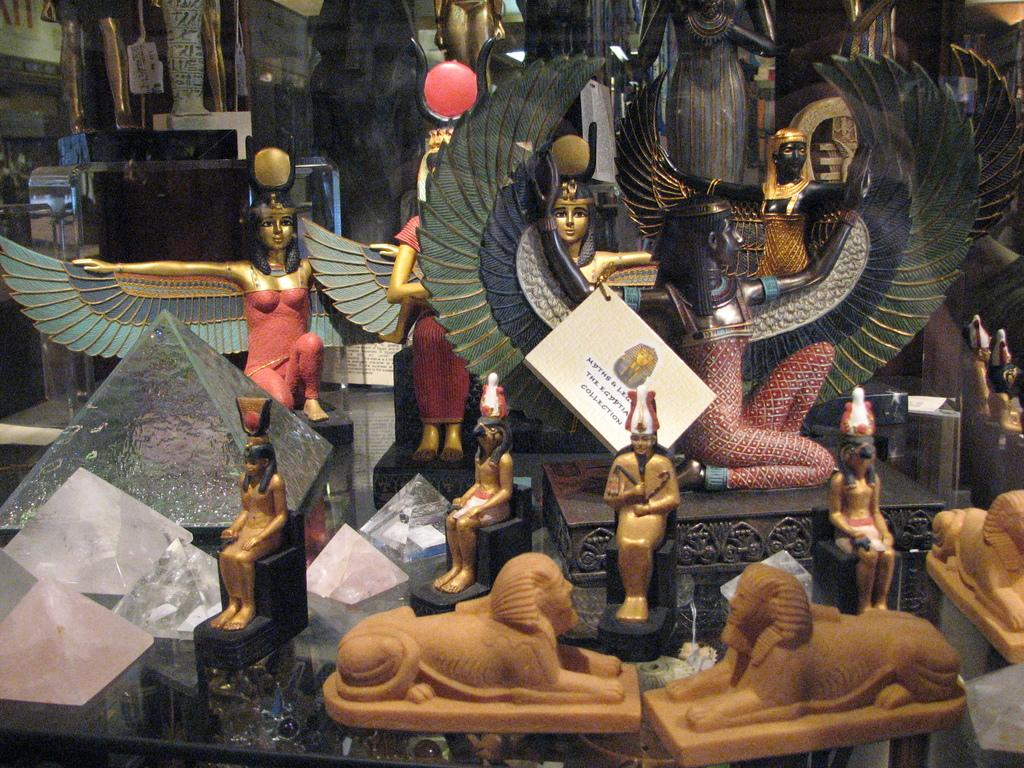What type of objects can be seen in the image? There are sculptures in the image. What type of polish is used to maintain the scarecrow sculpture in the image? There is no scarecrow sculpture present in the image, and therefore no polish can be associated with it. 